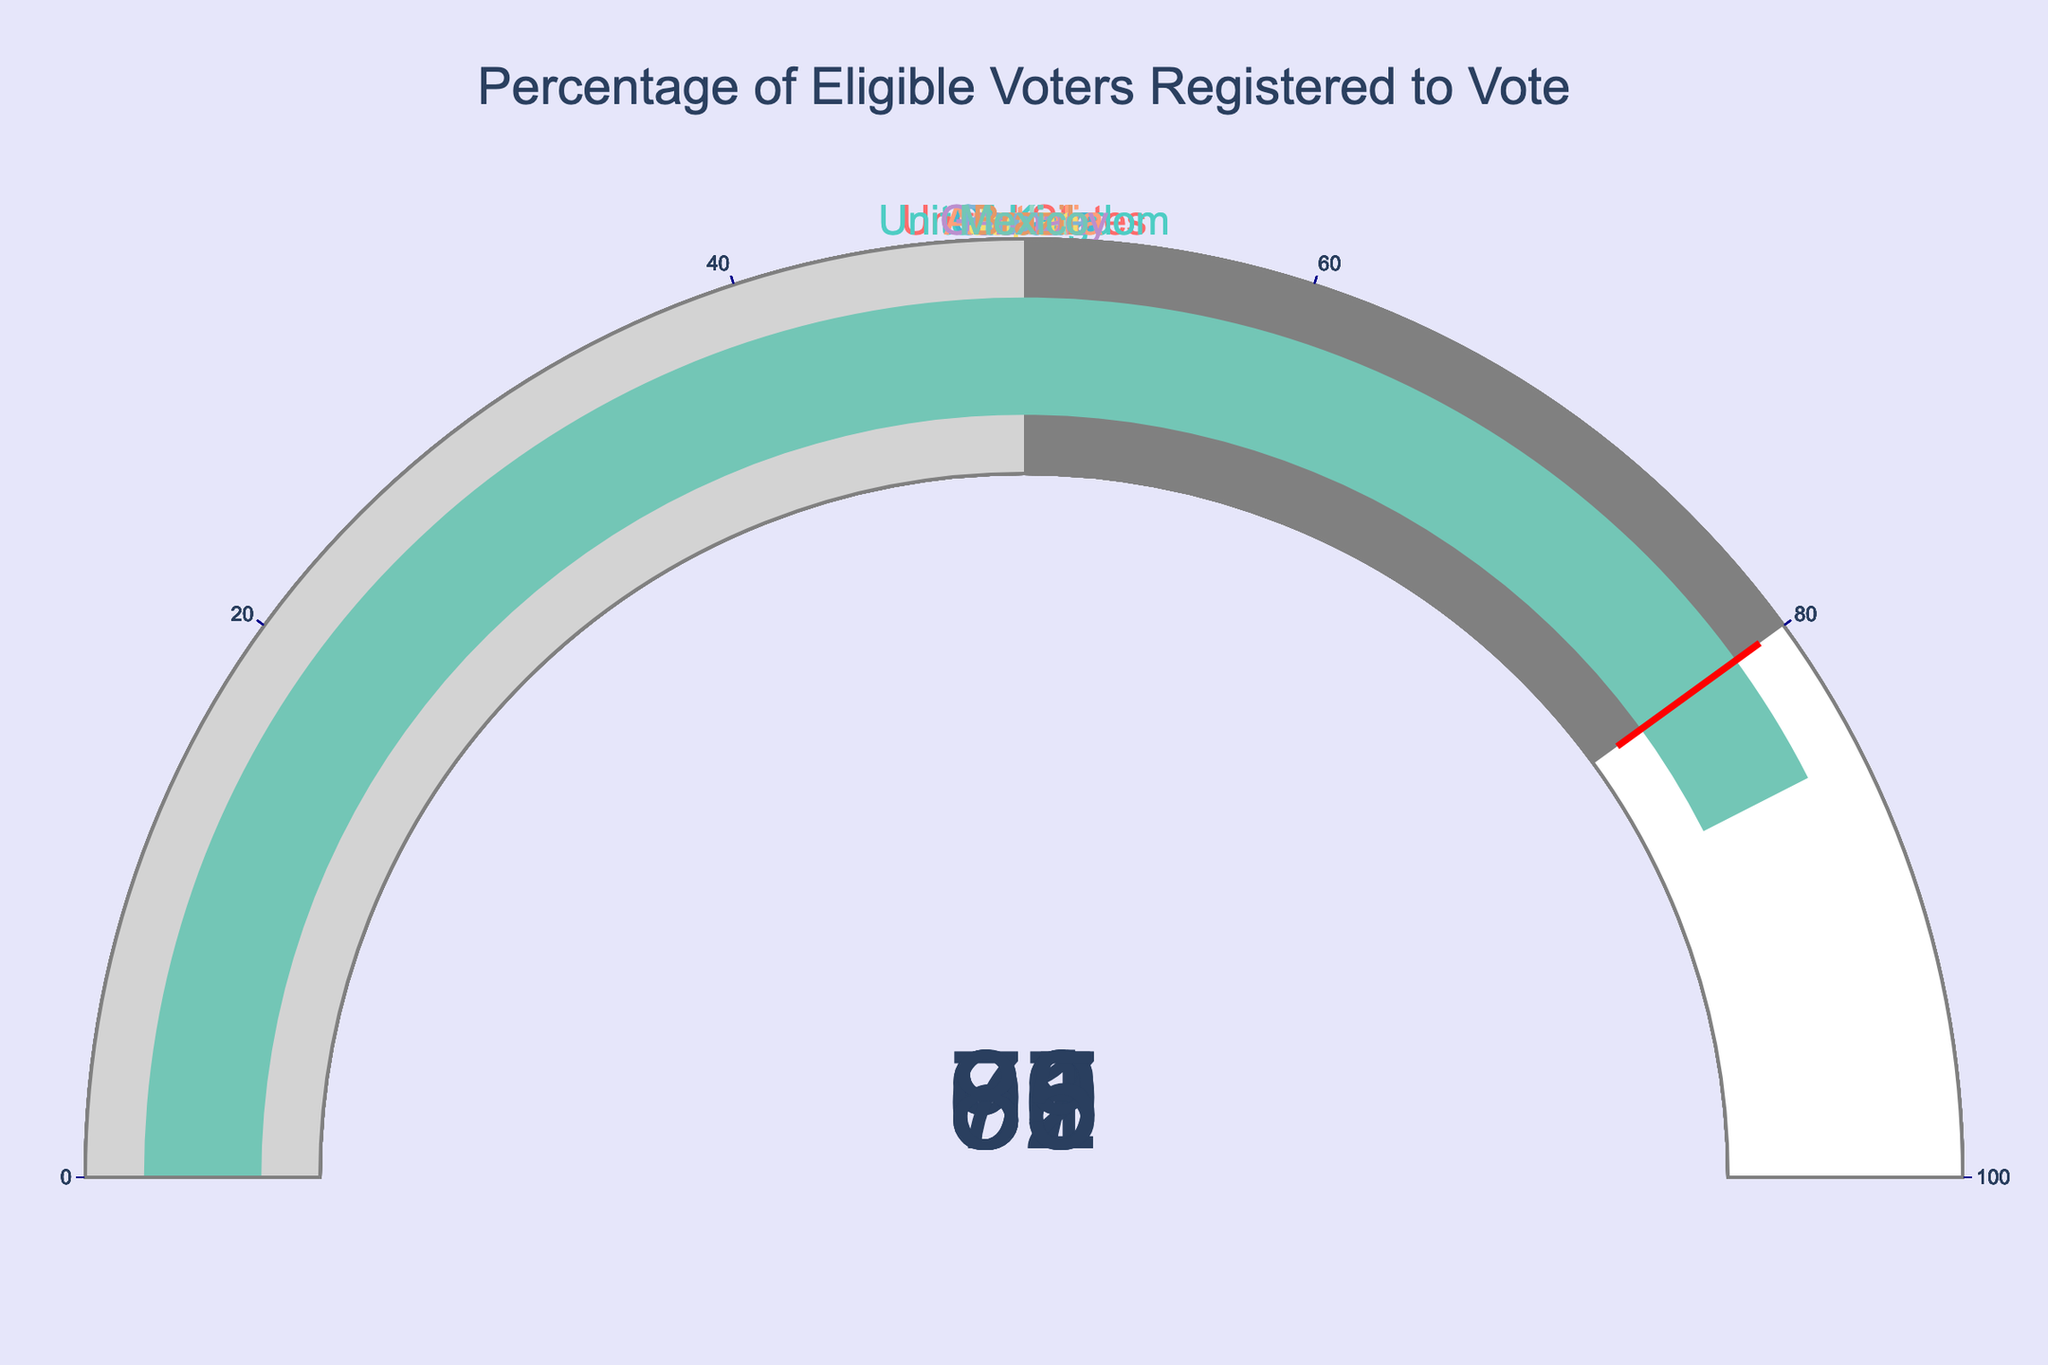What is the percentage of eligible voters registered to vote in the United States? The gauge chart shows the percentage of eligible voters registered to vote for each country, and the United States is marked with 67%.
Answer: 67% How many countries have a voter registration percentage above 80%? Count the number of countries with values over 80%. These are the United Kingdom, Canada, Australia, Japan, Germany, and France, totaling 6 countries.
Answer: 6 Which country has the highest voter registration percentage? Identify the gauge with the highest value. Australia has the highest percentage with 96%.
Answer: Australia What is the difference in voter registration percentages between Canada and India? Subtract India's percentage (62%) from Canada's percentage (91%). 91 - 62 = 29
Answer: 29 Which countries have a voter registration percentage lower than 70%? Look for gauges with values below 70%. The United States (67%) and India (62%) have percentages lower than 70%.
Answer: The United States and India What's the average voter registration percentage among all the listed countries? Sum all percentages: (67 + 92 + 91 + 96 + 62 + 83 + 88 + 89 + 79 + 85 = 832). Divide by the number of countries (10). 832 / 10 = 83.2
Answer: 83.2 What is the percentage difference between the highest and lowest voter registration values? Subtract the lowest value (62% for India) from the highest value (96% for Australia). 96 - 62 = 34
Answer: 34 Which country has a voter registration percentage closest to 90%? Look at the percentages and find the one closest to 90%. Both Canada (91%) and France (89%) are equally close, at 1% away +/-.
Answer: Canada and France List the countries in descending order of their voter registration percentages. List the countries starting from the highest percentage to the lowest: Australia (96%), United Kingdom (92%), Canada (91%), France (89%), Germany (88%), Japan (83%), Mexico (85%), Brazil (79%), United States (67%), India (62%).
Answer: Australia, United Kingdom, Canada, France, Germany, Japan, Mexico, Brazil, United States, India 